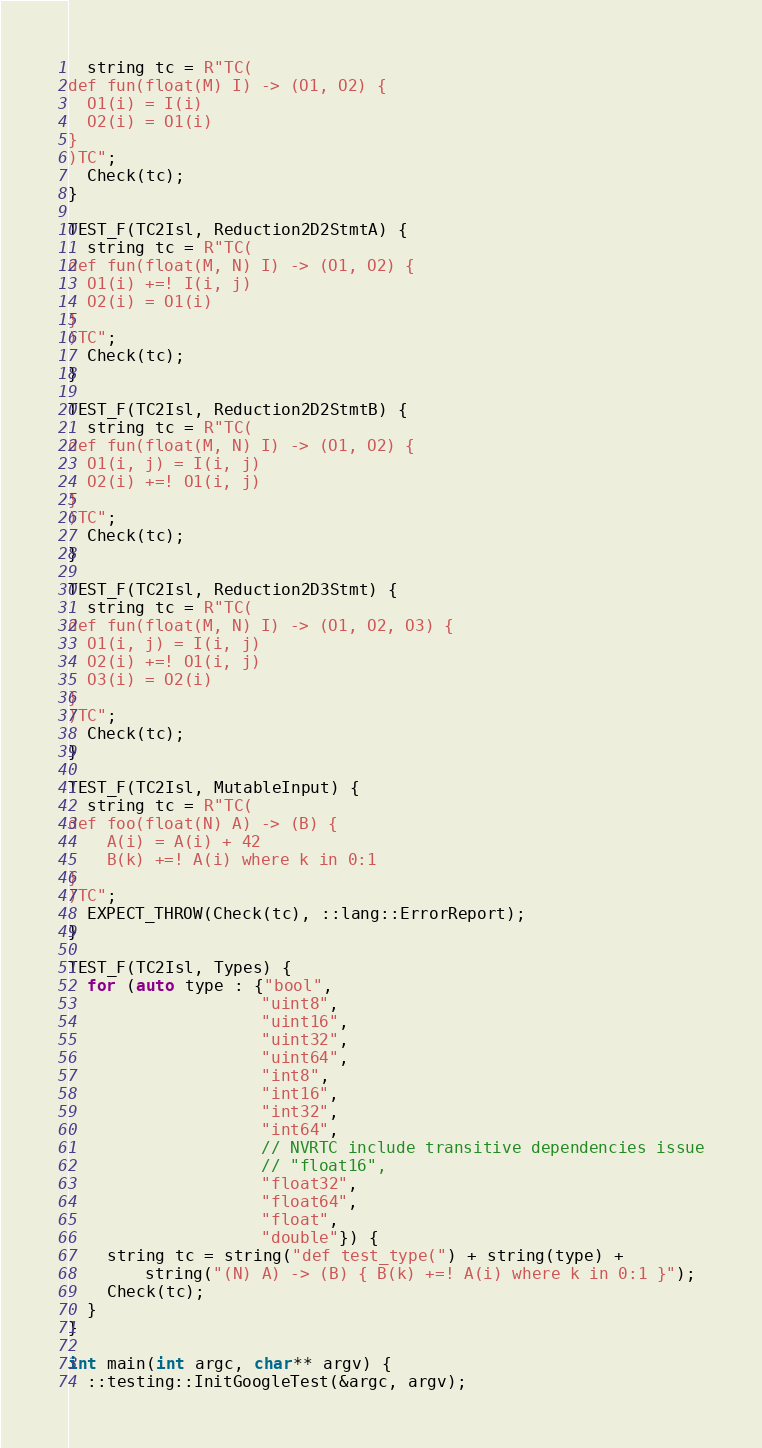Convert code to text. <code><loc_0><loc_0><loc_500><loc_500><_C++_>  string tc = R"TC(
def fun(float(M) I) -> (O1, O2) {
  O1(i) = I(i)
  O2(i) = O1(i)
}
)TC";
  Check(tc);
}

TEST_F(TC2Isl, Reduction2D2StmtA) {
  string tc = R"TC(
def fun(float(M, N) I) -> (O1, O2) {
  O1(i) +=! I(i, j)
  O2(i) = O1(i)
}
)TC";
  Check(tc);
}

TEST_F(TC2Isl, Reduction2D2StmtB) {
  string tc = R"TC(
def fun(float(M, N) I) -> (O1, O2) {
  O1(i, j) = I(i, j)
  O2(i) +=! O1(i, j)
}
)TC";
  Check(tc);
}

TEST_F(TC2Isl, Reduction2D3Stmt) {
  string tc = R"TC(
def fun(float(M, N) I) -> (O1, O2, O3) {
  O1(i, j) = I(i, j)
  O2(i) +=! O1(i, j)
  O3(i) = O2(i)
}
)TC";
  Check(tc);
}

TEST_F(TC2Isl, MutableInput) {
  string tc = R"TC(
def foo(float(N) A) -> (B) {
    A(i) = A(i) + 42
    B(k) +=! A(i) where k in 0:1
}
)TC";
  EXPECT_THROW(Check(tc), ::lang::ErrorReport);
}

TEST_F(TC2Isl, Types) {
  for (auto type : {"bool",
                    "uint8",
                    "uint16",
                    "uint32",
                    "uint64",
                    "int8",
                    "int16",
                    "int32",
                    "int64",
                    // NVRTC include transitive dependencies issue
                    // "float16",
                    "float32",
                    "float64",
                    "float",
                    "double"}) {
    string tc = string("def test_type(") + string(type) +
        string("(N) A) -> (B) { B(k) +=! A(i) where k in 0:1 }");
    Check(tc);
  }
}

int main(int argc, char** argv) {
  ::testing::InitGoogleTest(&argc, argv);</code> 